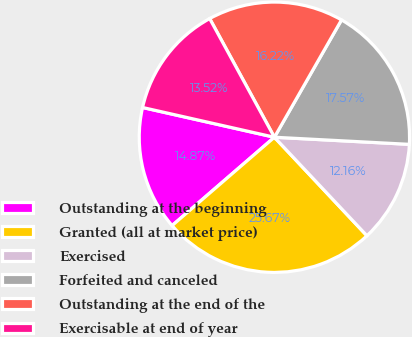Convert chart to OTSL. <chart><loc_0><loc_0><loc_500><loc_500><pie_chart><fcel>Outstanding at the beginning<fcel>Granted (all at market price)<fcel>Exercised<fcel>Forfeited and canceled<fcel>Outstanding at the end of the<fcel>Exercisable at end of year<nl><fcel>14.87%<fcel>25.67%<fcel>12.16%<fcel>17.57%<fcel>16.22%<fcel>13.52%<nl></chart> 